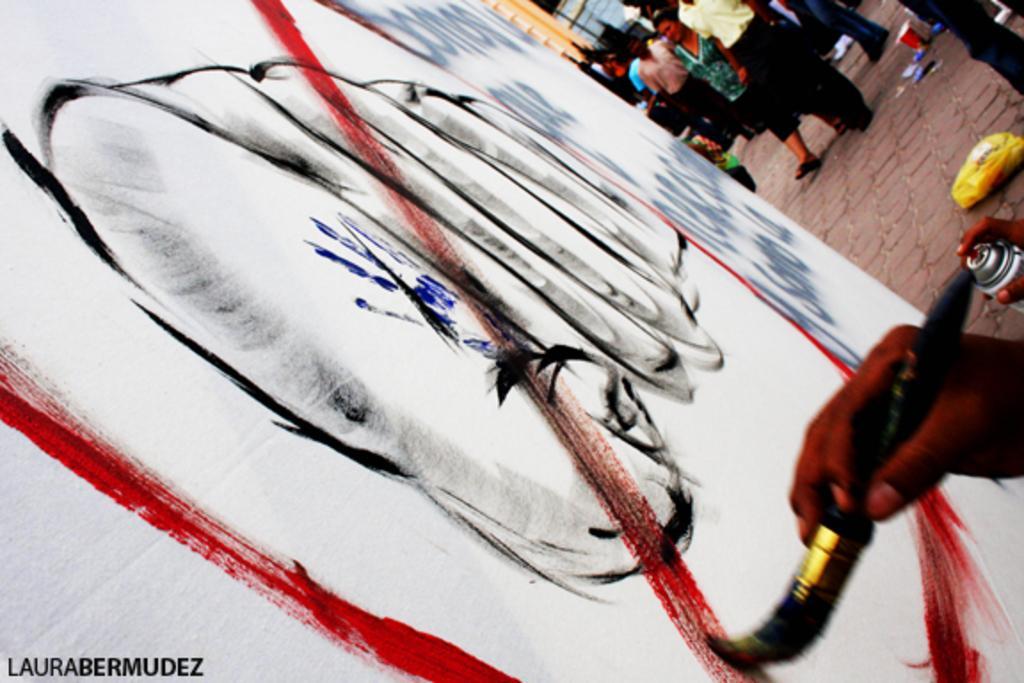Describe this image in one or two sentences. In the picture we can see some person holding paint brush in his hands and painting and in the background of the picture there are some persons standing. 